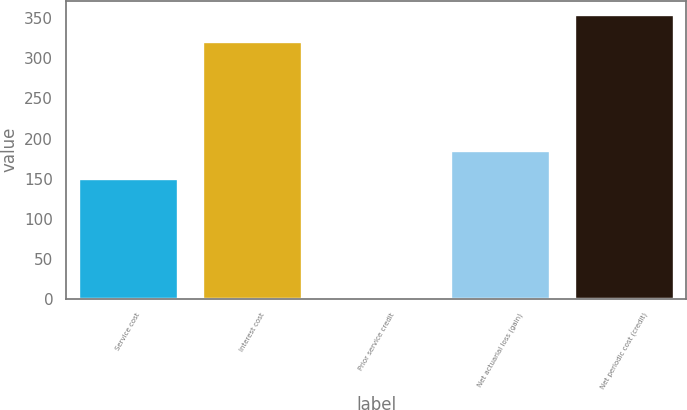<chart> <loc_0><loc_0><loc_500><loc_500><bar_chart><fcel>Service cost<fcel>Interest cost<fcel>Prior service credit<fcel>Net actuarial loss (gain)<fcel>Net periodic cost (credit)<nl><fcel>150<fcel>320<fcel>2<fcel>184.3<fcel>354.3<nl></chart> 